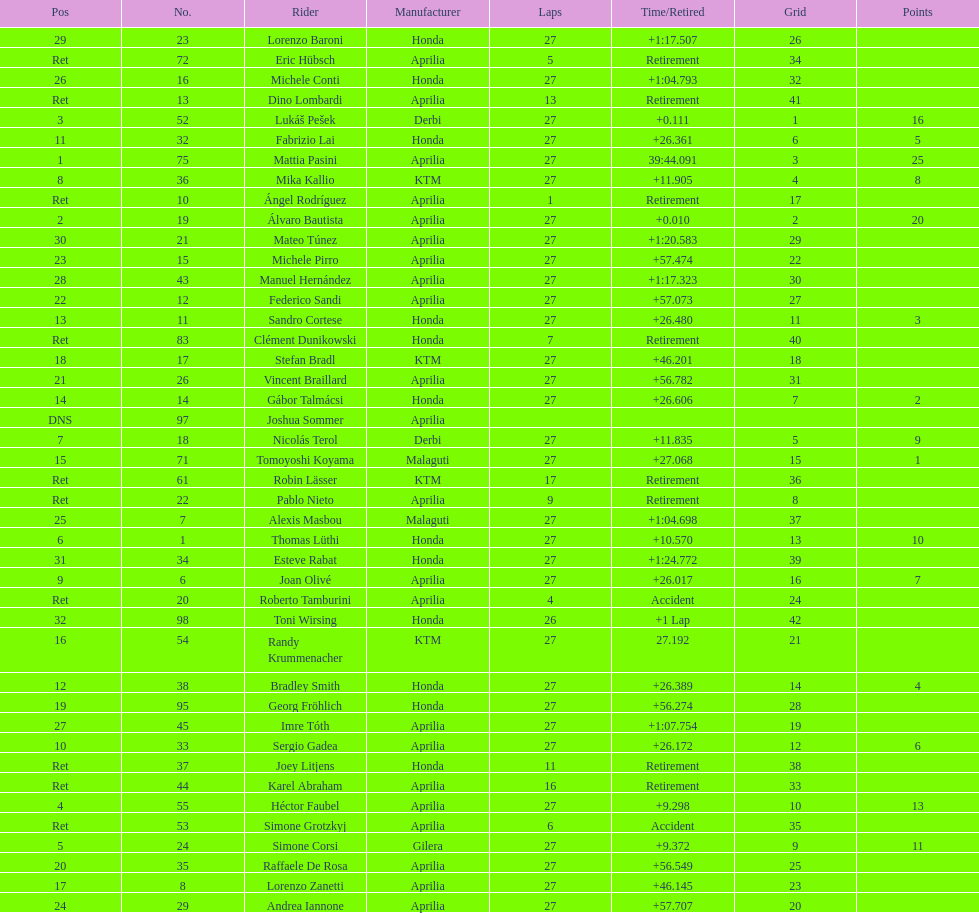Who ranked higher, bradl or gadea? Sergio Gadea. 